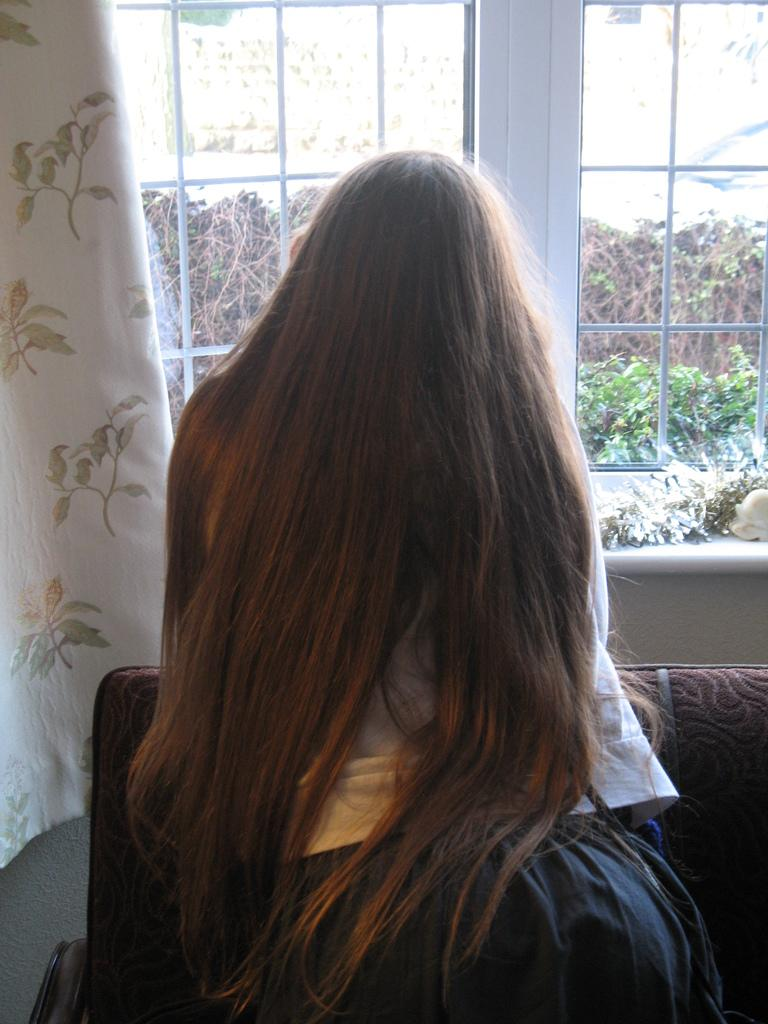Who or what is present in the image? There is a person in the image. What is in front of the person? There is a couch in front of the person. What can be seen near the window? There are curtains associated with the window. What is visible through the window? Trees are visible through the window. How many girls are flying a plane in the image? There are no girls or planes present in the image. What type of crook can be seen in the image? There is no crook present in the image. 